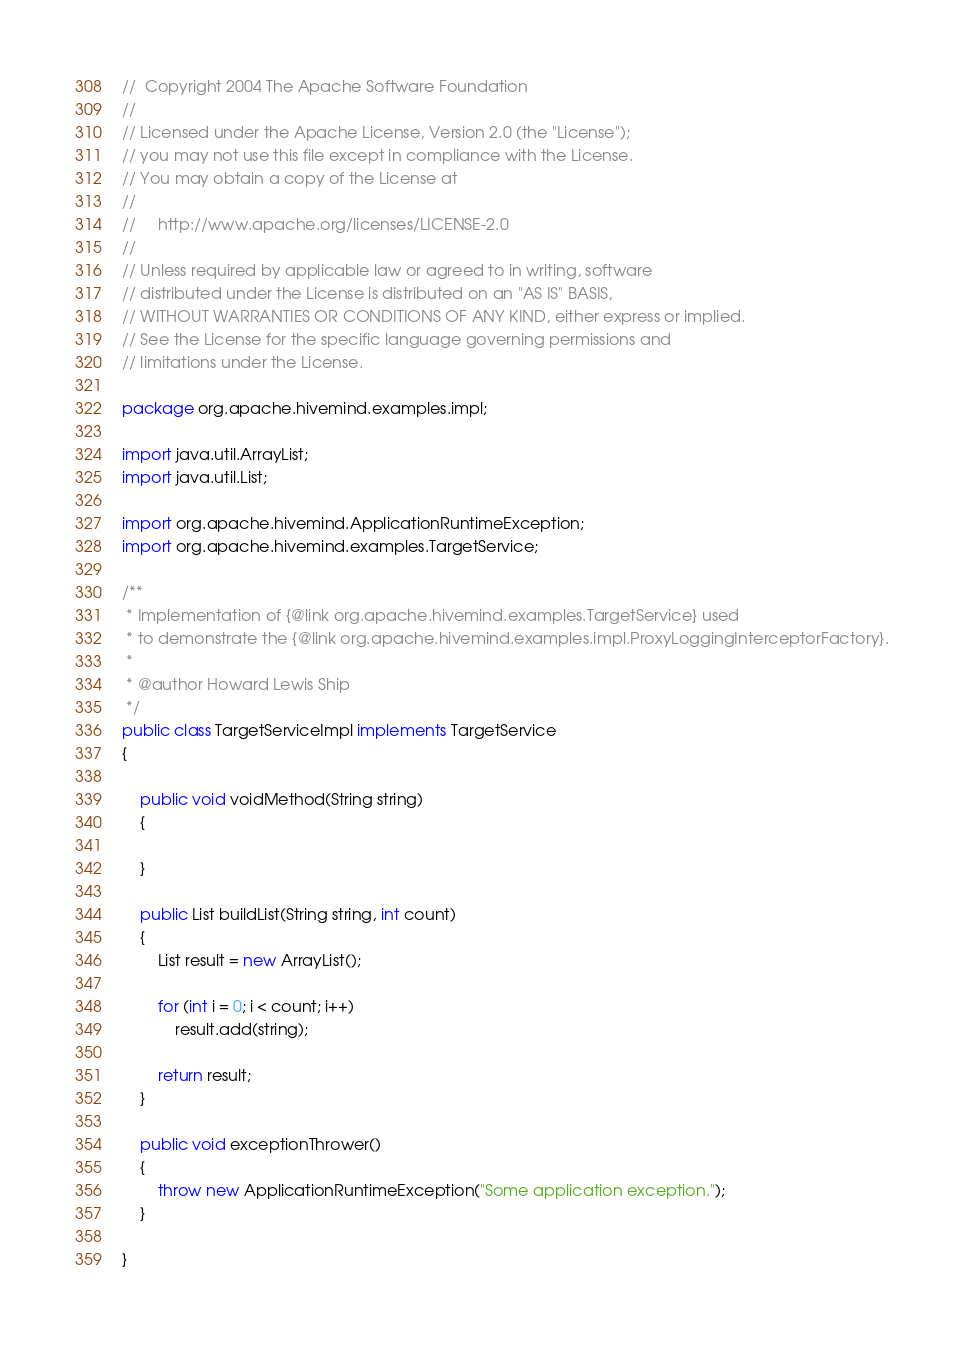<code> <loc_0><loc_0><loc_500><loc_500><_Java_>//  Copyright 2004 The Apache Software Foundation
//
// Licensed under the Apache License, Version 2.0 (the "License");
// you may not use this file except in compliance with the License.
// You may obtain a copy of the License at
//
//     http://www.apache.org/licenses/LICENSE-2.0
//
// Unless required by applicable law or agreed to in writing, software
// distributed under the License is distributed on an "AS IS" BASIS,
// WITHOUT WARRANTIES OR CONDITIONS OF ANY KIND, either express or implied.
// See the License for the specific language governing permissions and
// limitations under the License.

package org.apache.hivemind.examples.impl;

import java.util.ArrayList;
import java.util.List;

import org.apache.hivemind.ApplicationRuntimeException;
import org.apache.hivemind.examples.TargetService;

/**
 * Implementation of {@link org.apache.hivemind.examples.TargetService} used
 * to demonstrate the {@link org.apache.hivemind.examples.impl.ProxyLoggingInterceptorFactory}.
 *
 * @author Howard Lewis Ship
 */
public class TargetServiceImpl implements TargetService
{

    public void voidMethod(String string)
    {

    }

    public List buildList(String string, int count)
    {
        List result = new ArrayList();
        
        for (int i = 0; i < count; i++)
            result.add(string);

        return result;
    }

    public void exceptionThrower()
    {
        throw new ApplicationRuntimeException("Some application exception.");
    }

}
</code> 